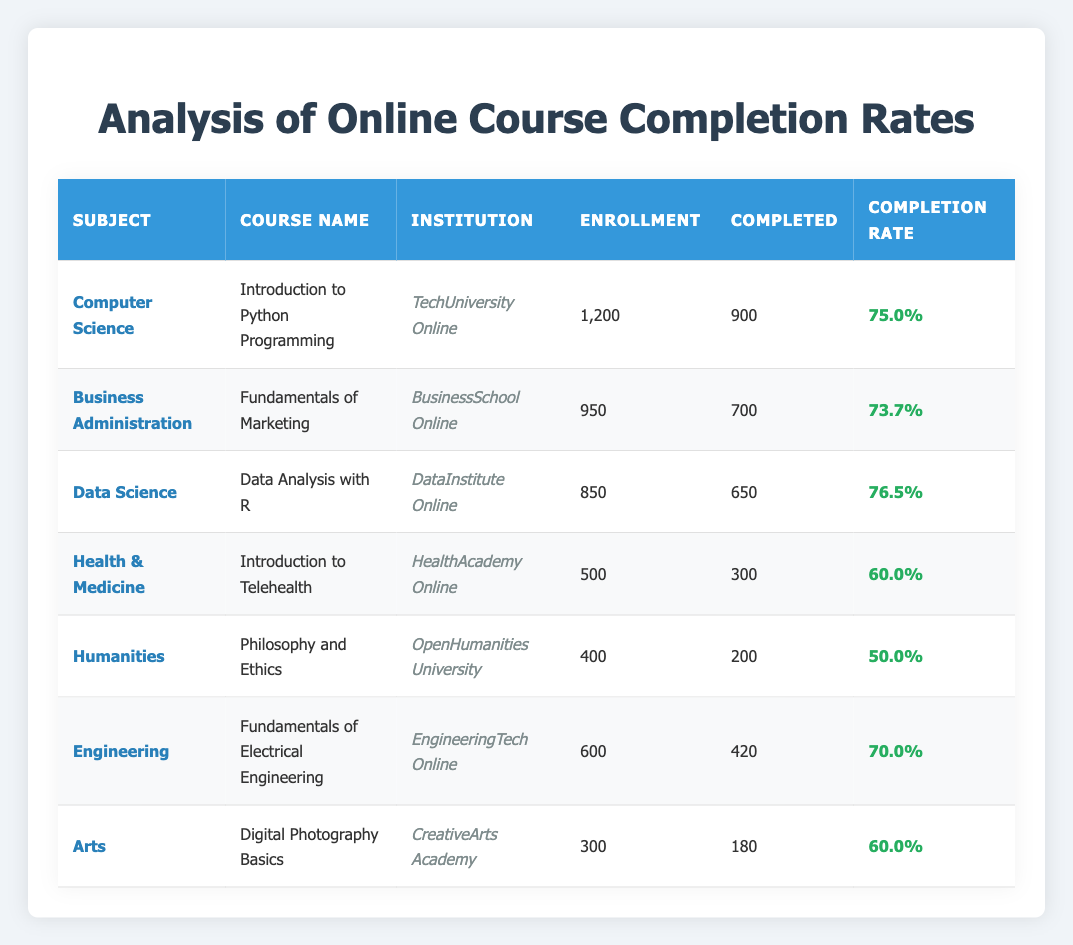What is the highest course completion rate in the table? Looking through the completion rates for each course, the highest rate is 76.5% for the course "Data Analysis with R" from DataInstitute Online.
Answer: 76.5% Which institution offers the course with the lowest completion rate? Reviewing the completion rates, the course "Philosophy and Ethics" from OpenHumanities University has the lowest completion rate at 50.0%.
Answer: OpenHumanities University What is the average completion rate of all courses listed? To find the average, sum the completion rates (75.0 + 73.7 + 76.5 + 60.0 + 50.0 + 70.0 + 60.0 = 465.2) and divide by the number of courses (7). Thus, the average completion rate is 465.2 / 7 = 66.5%.
Answer: 66.5% Is there a course in the table that has an enrollment of more than 1000 students? Yes, the course "Introduction to Python Programming" has an enrollment of 1200 students, which is greater than 1000.
Answer: Yes Which subject has the highest number of enrollments? When comparing the number of enrollments, the subject "Computer Science" with the course "Introduction to Python Programming" has the highest enrollment of 1200.
Answer: Computer Science 